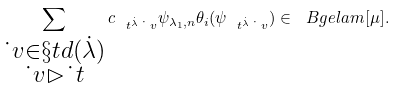<formula> <loc_0><loc_0><loc_500><loc_500>\sum _ { \substack { \dot { \ } v \in \S t d ( \dot { \lambda } ) \\ \dot { \ } v \rhd \dot { \ } t } } c _ { \ t ^ { \dot { \lambda } } \dot { \ } v } \psi _ { \lambda _ { 1 } , n } \theta _ { i } ( \psi _ { \ t ^ { \dot { \lambda } } \dot { \ } v } ) \in \ B g e l a m [ \mu ] .</formula> 